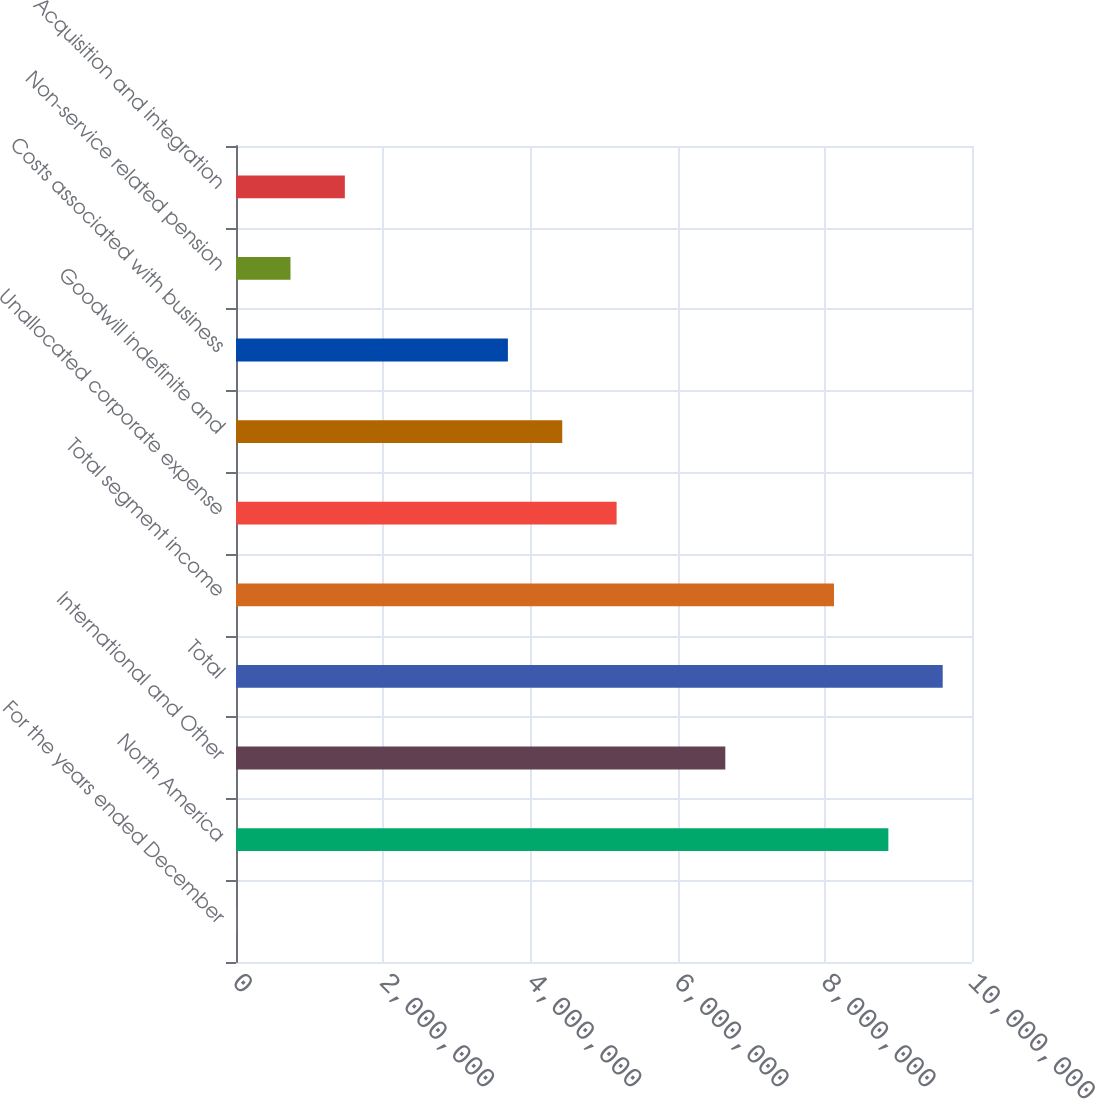<chart> <loc_0><loc_0><loc_500><loc_500><bar_chart><fcel>For the years ended December<fcel>North America<fcel>International and Other<fcel>Total<fcel>Total segment income<fcel>Unallocated corporate expense<fcel>Goodwill indefinite and<fcel>Costs associated with business<fcel>Non-service related pension<fcel>Acquisition and integration<nl><fcel>2015<fcel>8.86355e+06<fcel>6.64816e+06<fcel>9.60201e+06<fcel>8.12509e+06<fcel>5.17124e+06<fcel>4.43278e+06<fcel>3.69432e+06<fcel>740476<fcel>1.47894e+06<nl></chart> 